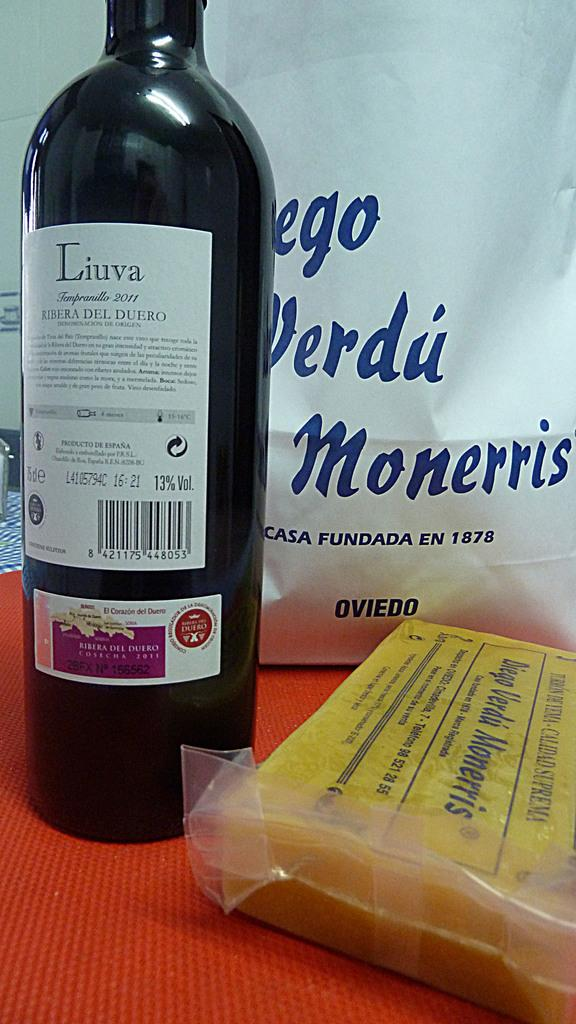<image>
Offer a succinct explanation of the picture presented. the word Liuva that is on a wine bottle 